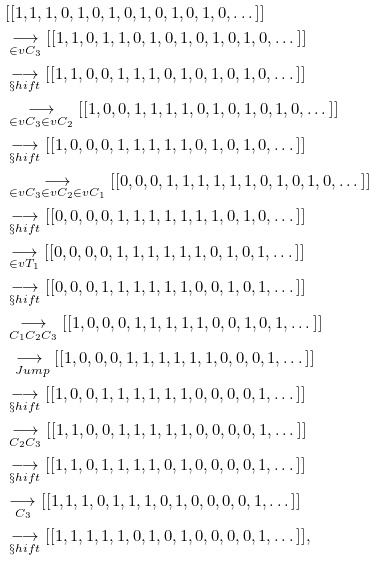Convert formula to latex. <formula><loc_0><loc_0><loc_500><loc_500>& [ [ 1 , 1 , 1 , 0 , 1 , 0 , 1 , 0 , 1 , 0 , 1 , 0 , 1 , 0 , \dots ] ] \\ & \underset { \in v { C _ { 3 } } } { \longrightarrow } [ [ 1 , 1 , 0 , 1 , 1 , 0 , 1 , 0 , 1 , 0 , 1 , 0 , 1 , 0 , \dots ] ] \\ & \underset { \S h i f t } { \longrightarrow } [ [ 1 , 1 , 0 , 0 , 1 , 1 , 1 , 0 , 1 , 0 , 1 , 0 , 1 , 0 , \dots ] ] \\ & \underset { \in v { C _ { 3 } } \in v { C _ { 2 } } } { \longrightarrow } [ [ 1 , 0 , 0 , 1 , 1 , 1 , 1 , 0 , 1 , 0 , 1 , 0 , 1 , 0 , \dots ] ] \\ & \underset { \S h i f t } { \longrightarrow } [ [ 1 , 0 , 0 , 0 , 1 , 1 , 1 , 1 , 1 , 0 , 1 , 0 , 1 , 0 , \dots ] ] \\ & \underset { \in v { C _ { 3 } } \in v { C _ { 2 } } \in v { C _ { 1 } } } { \longrightarrow } [ [ 0 , 0 , 0 , 1 , 1 , 1 , 1 , 1 , 1 , 0 , 1 , 0 , 1 , 0 , \dots ] ] \\ & \underset { \S h i f t } { \longrightarrow } [ [ 0 , 0 , 0 , 0 , 1 , 1 , 1 , 1 , 1 , 1 , 1 , 0 , 1 , 0 , \dots ] ] \\ & \underset { \in v { T _ { 1 } } } { \longrightarrow } [ [ 0 , 0 , 0 , 0 , 1 , 1 , 1 , 1 , 1 , 1 , 0 , 1 , 0 , 1 , \dots ] ] \\ & \underset { \S h i f t } { \longrightarrow } [ [ 0 , 0 , 0 , 1 , 1 , 1 , 1 , 1 , 1 , 0 , 0 , 1 , 0 , 1 , \dots ] ] \\ & \underset { C _ { 1 } C _ { 2 } C _ { 3 } } { \longrightarrow } [ [ 1 , 0 , 0 , 0 , 1 , 1 , 1 , 1 , 1 , 0 , 0 , 1 , 0 , 1 , \dots ] ] \\ & \underset { \ J u m p } { \longrightarrow } [ [ 1 , 0 , 0 , 0 , 1 , 1 , 1 , 1 , 1 , 1 , 0 , 0 , 0 , 1 , \dots ] ] \\ & \underset { \S h i f t } { \longrightarrow } [ [ 1 , 0 , 0 , 1 , 1 , 1 , 1 , 1 , 1 , 0 , 0 , 0 , 0 , 1 , \dots ] ] \\ & \underset { C _ { 2 } C _ { 3 } } { \longrightarrow } [ [ 1 , 1 , 0 , 0 , 1 , 1 , 1 , 1 , 1 , 0 , 0 , 0 , 0 , 1 , \dots ] ] \\ & \underset { \S h i f t } { \longrightarrow } [ [ 1 , 1 , 0 , 1 , 1 , 1 , 1 , 0 , 1 , 0 , 0 , 0 , 0 , 1 , \dots ] ] \\ & \underset { C _ { 3 } } { \longrightarrow } [ [ 1 , 1 , 1 , 0 , 1 , 1 , 1 , 0 , 1 , 0 , 0 , 0 , 0 , 1 , \dots ] ] \\ & \underset { \S h i f t } { \longrightarrow } [ [ 1 , 1 , 1 , 1 , 1 , 0 , 1 , 0 , 1 , 0 , 0 , 0 , 0 , 1 , \dots ] ] ,</formula> 